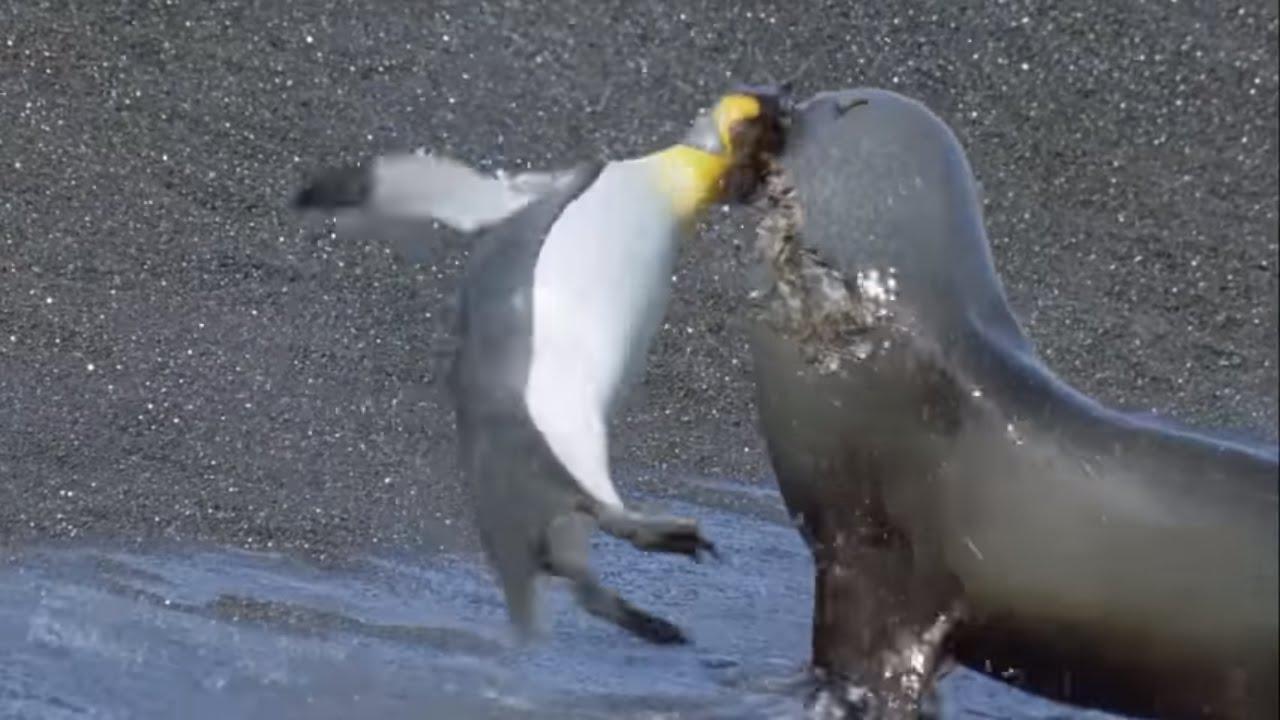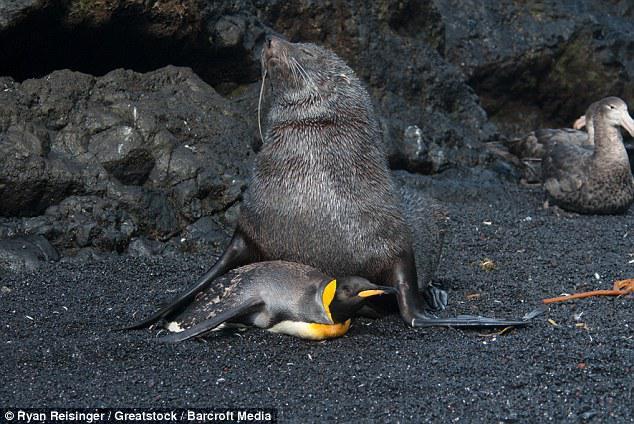The first image is the image on the left, the second image is the image on the right. Given the left and right images, does the statement "One of the images shows a penguin that is brown and fuzzy standing near a black and white penguin." hold true? Answer yes or no. No. The first image is the image on the left, the second image is the image on the right. Assess this claim about the two images: "A seal photobombs in the lower right corner of one of the pictures.". Correct or not? Answer yes or no. No. 